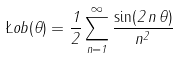Convert formula to latex. <formula><loc_0><loc_0><loc_500><loc_500>\L o b ( \theta ) = \frac { 1 } { 2 } \sum _ { n = 1 } ^ { \infty } \frac { \sin ( 2 \, n \, \theta ) } { n ^ { 2 } }</formula> 